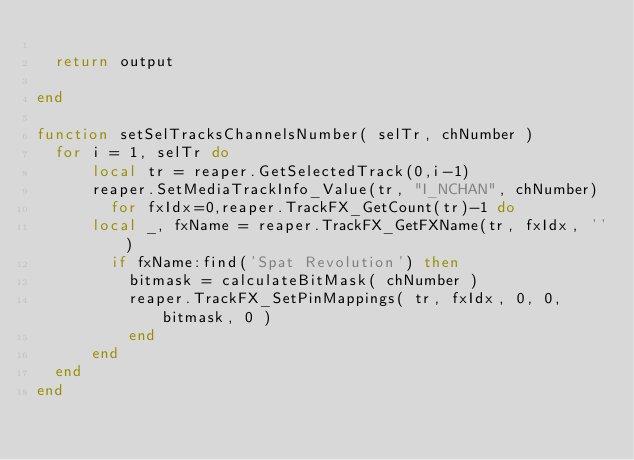<code> <loc_0><loc_0><loc_500><loc_500><_Lua_>
  return output

end

function setSelTracksChannelsNumber( selTr, chNumber )
  for i = 1, selTr do
      local tr = reaper.GetSelectedTrack(0,i-1)
      reaper.SetMediaTrackInfo_Value(tr, "I_NCHAN", chNumber)
        for fxIdx=0,reaper.TrackFX_GetCount(tr)-1 do
      local _, fxName = reaper.TrackFX_GetFXName(tr, fxIdx, '')
        if fxName:find('Spat Revolution') then
          bitmask = calculateBitMask( chNumber )
          reaper.TrackFX_SetPinMappings( tr, fxIdx, 0, 0, bitmask, 0 )
          end
      end
  end
end</code> 